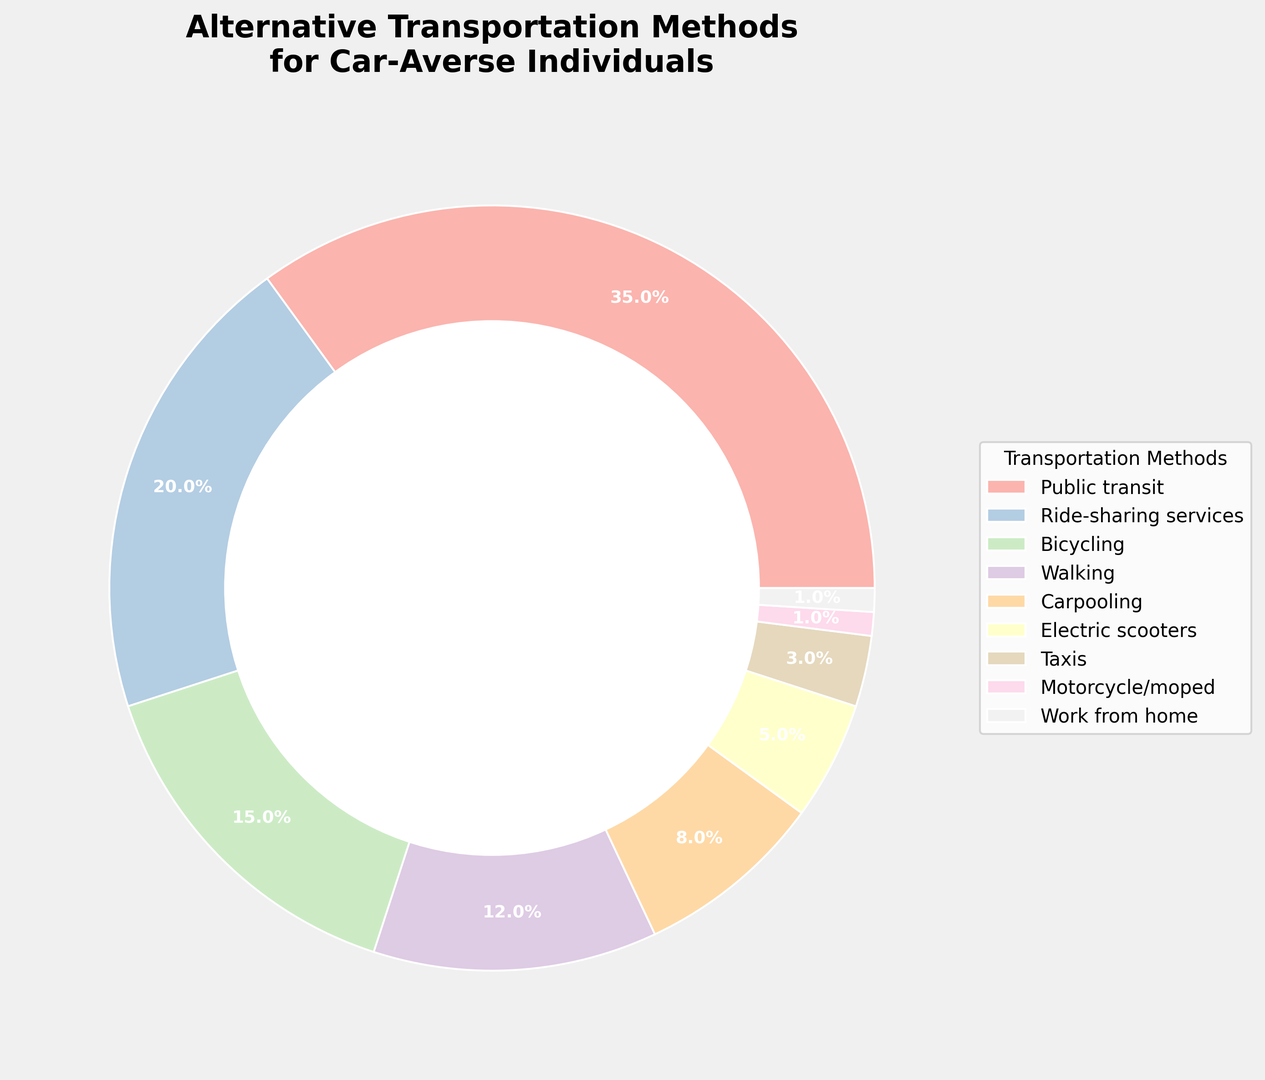What transportation method has the highest percentage? By looking at the ring chart, identify the segment with the largest area. The method with the highest percentage will have the largest area on the chart.
Answer: Public transit Which two transportation methods together make up more than half of the chart? Sum the percentages of different methods and find the two methods whose combined percentage exceeds 50%. Public transit (35%) and Ride-sharing services (20%) together make 55%.
Answer: Public transit and Ride-sharing services Is the percentage of people using electric scooters greater than those using taxis? Compare the chart segments representing 'Electric scooters' and 'Taxis'. Electric scooters have a larger segment (5%) compared to Taxis (3%).
Answer: Yes What is the percentage difference between bicycling and walking? Subtract the percentage of walking (12%) from the percentage of bicycling (15%). The difference is 15% - 12% = 3%.
Answer: 3% Which transportation method has the smallest percentage? Look for the smallest segment in the ring chart. 'Motorcycle/moped' has the smallest segment with 1%.
Answer: Motorcycle/moped How many methods have a higher percentage than carpooling? Identify the segments larger than that for 'Carpooling' (8%). These are Public transit, Ride-sharing services, Bicycling, and Walking. Counting these reveals there are 4 methods.
Answer: 4 methods Are there any two adjacent transportation methods whose combined percentage is equal to that of Public transit? Find two methods whose percentages sum up to 35%. Ride-sharing services (20%) and Bicycling (15%) together make 35%.
Answer: Ride-sharing services and Bicycling Which segment is colored the lightest in the chart and what transportation method does it represent? The ring chart uses a color gradient, and the lightest color would be the first segment, which represents 'Public transit'.
Answer: Public transit Based on the percentages in the chart, what is the average percentage of all the transportation methods? Add all the percentages and divide by the number of methods. Total percentage = 100%, and there are 9 methods. Average = 100% / 9 ≈ 11.1%.
Answer: 11.1% Which method has a segment that is roughly half the size of the 'Public transit' segment? Public transit is 35%. A segment roughly half its size would be around 17.5%. 'Ride-sharing services' is close at 20%.
Answer: Ride-sharing services 